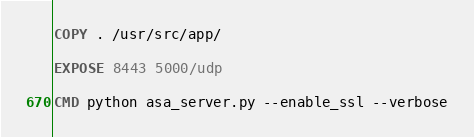<code> <loc_0><loc_0><loc_500><loc_500><_Dockerfile_>
COPY . /usr/src/app/

EXPOSE 8443 5000/udp

CMD python asa_server.py --enable_ssl --verbose
</code> 